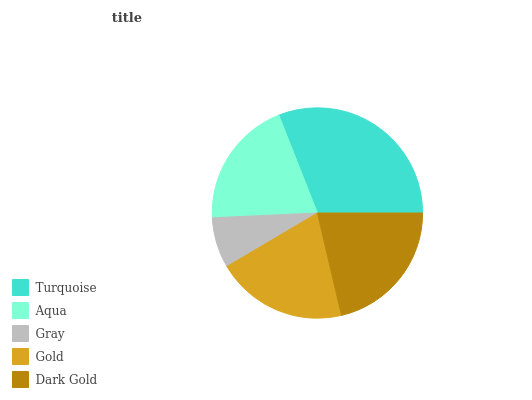Is Gray the minimum?
Answer yes or no. Yes. Is Turquoise the maximum?
Answer yes or no. Yes. Is Aqua the minimum?
Answer yes or no. No. Is Aqua the maximum?
Answer yes or no. No. Is Turquoise greater than Aqua?
Answer yes or no. Yes. Is Aqua less than Turquoise?
Answer yes or no. Yes. Is Aqua greater than Turquoise?
Answer yes or no. No. Is Turquoise less than Aqua?
Answer yes or no. No. Is Gold the high median?
Answer yes or no. Yes. Is Gold the low median?
Answer yes or no. Yes. Is Turquoise the high median?
Answer yes or no. No. Is Turquoise the low median?
Answer yes or no. No. 